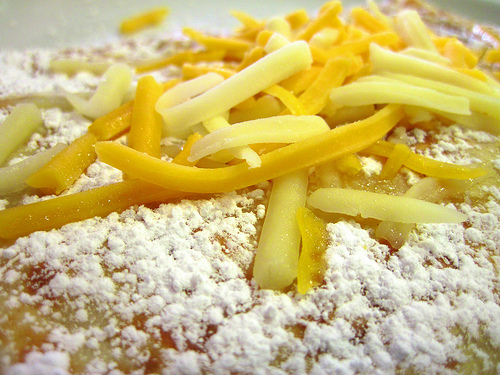<image>
Can you confirm if the strips is on the sugar? Yes. Looking at the image, I can see the strips is positioned on top of the sugar, with the sugar providing support. 